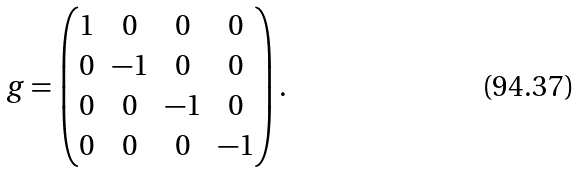<formula> <loc_0><loc_0><loc_500><loc_500>g = \begin{pmatrix} 1 & 0 & 0 & 0 \\ 0 & - 1 & 0 & 0 \\ 0 & 0 & - 1 & 0 \\ 0 & 0 & 0 & - 1 \end{pmatrix} .</formula> 